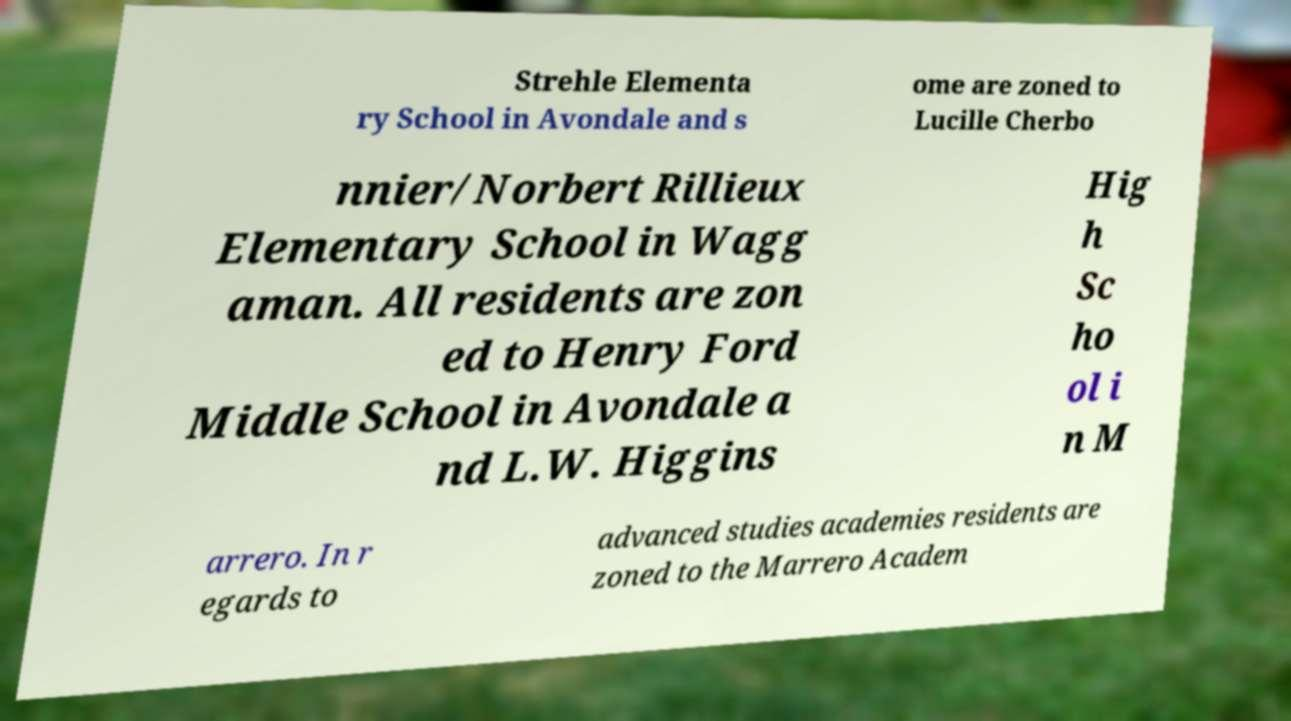Please identify and transcribe the text found in this image. Strehle Elementa ry School in Avondale and s ome are zoned to Lucille Cherbo nnier/Norbert Rillieux Elementary School in Wagg aman. All residents are zon ed to Henry Ford Middle School in Avondale a nd L.W. Higgins Hig h Sc ho ol i n M arrero. In r egards to advanced studies academies residents are zoned to the Marrero Academ 